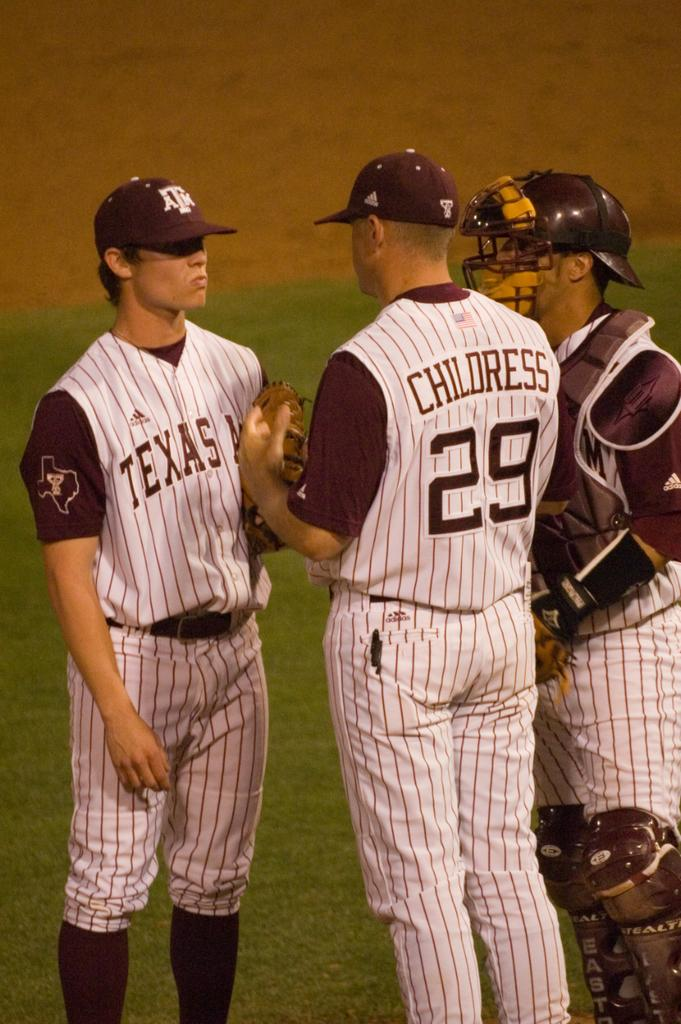<image>
Create a compact narrative representing the image presented. Three Baseball player from Texas A&M having a conversation. 